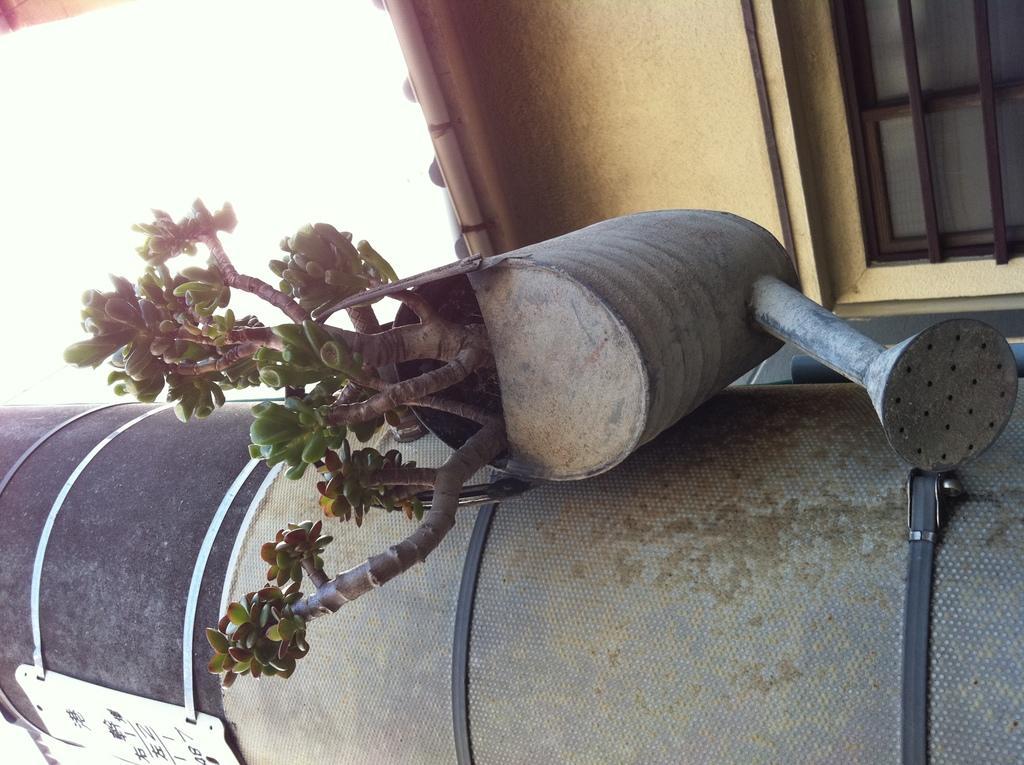Can you describe this image briefly? In this image we can see a pillar to which we can see watering can with plant in it. In the background, we can see windows, house and the sky. 